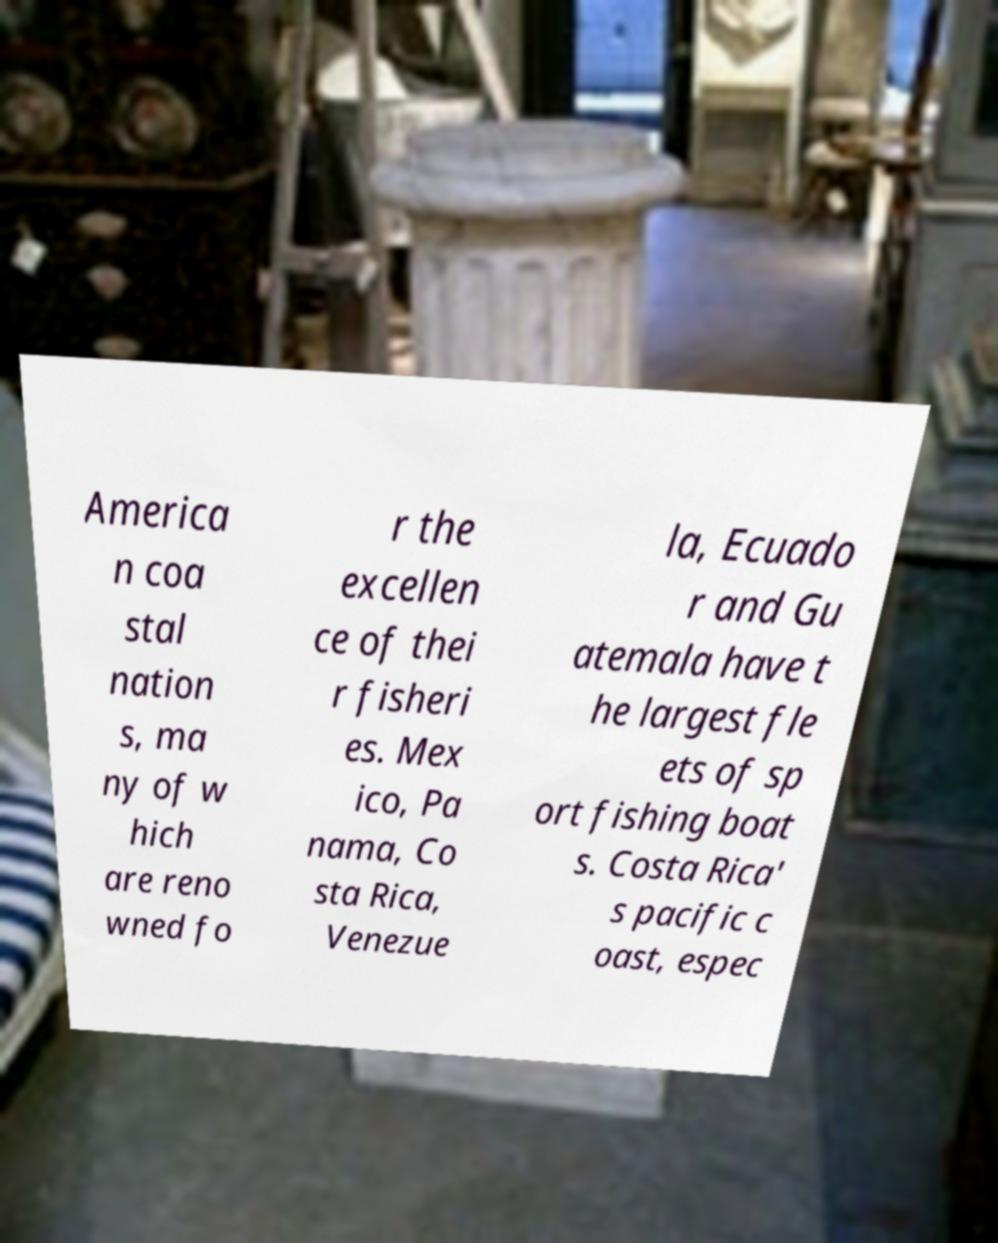What messages or text are displayed in this image? I need them in a readable, typed format. America n coa stal nation s, ma ny of w hich are reno wned fo r the excellen ce of thei r fisheri es. Mex ico, Pa nama, Co sta Rica, Venezue la, Ecuado r and Gu atemala have t he largest fle ets of sp ort fishing boat s. Costa Rica' s pacific c oast, espec 